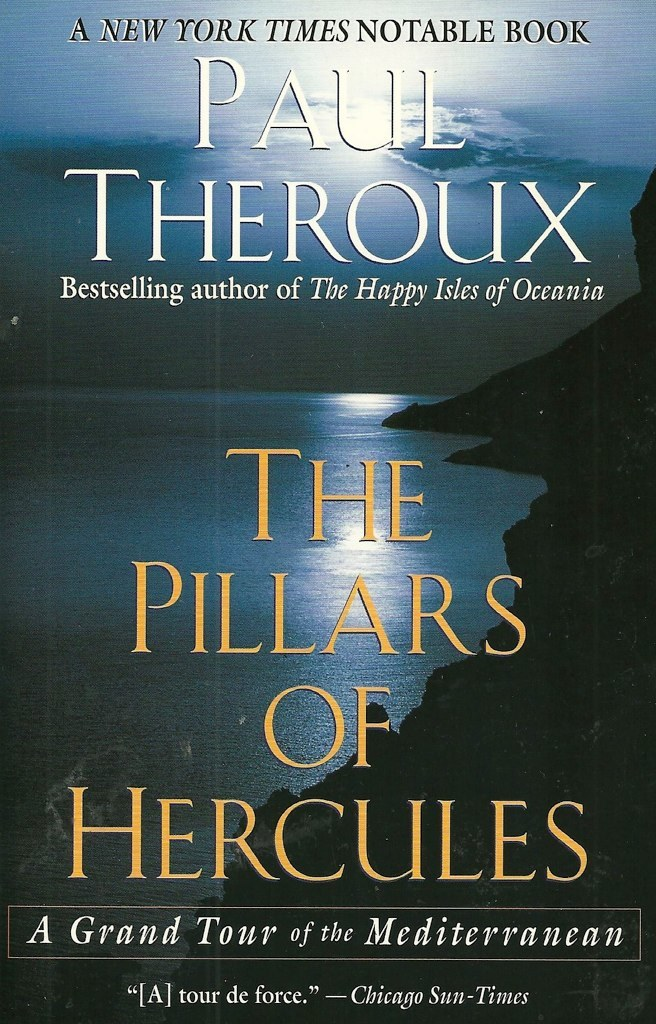Can you tell me more about what 'The Pillars of Hercules' refers to in this context? 'The Pillars of Hercules' historically refers to the promontories that flank the entrance to the Strait of Gibraltar, marking the gateway from the Atlantic Ocean to the Mediterranean Sea. In the context of Paul Theroux's book, it symbolizes the exploration and adventures across different Mediterranean cultures and landscapes, bridging the literal and metaphorical doorways between various histories and geographies encountered upon this journey. 